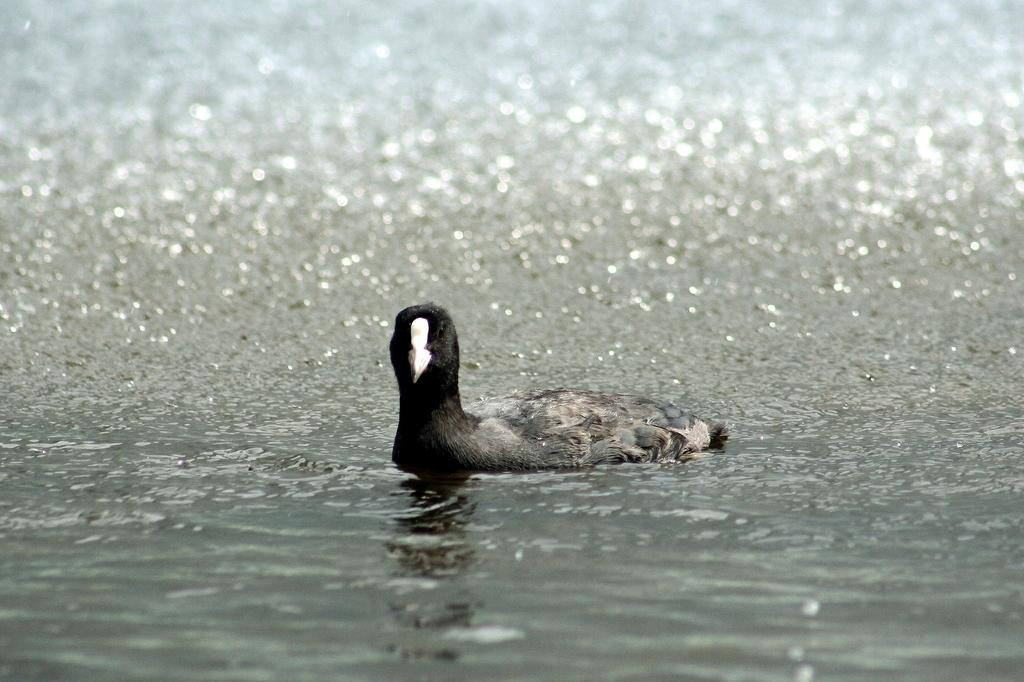What animal is present in the image? There is a duck in the image. Where is the duck located in the image? The duck is present over a place covered with water. What type of treatment is the duck receiving in the image? There is no indication in the image that the duck is receiving any treatment. 